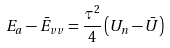<formula> <loc_0><loc_0><loc_500><loc_500>E _ { a } - \bar { E } _ { v v } = \frac { \tau ^ { 2 } } 4 \left ( U _ { n } - \bar { U } \right )</formula> 